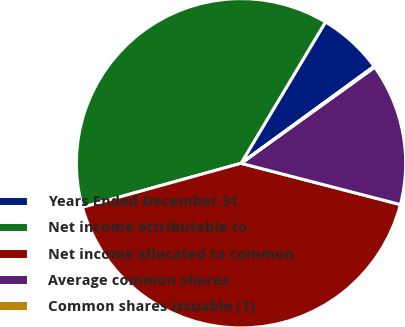<chart> <loc_0><loc_0><loc_500><loc_500><pie_chart><fcel>Years Ended December 31<fcel>Net income attributable to<fcel>Net income allocated to common<fcel>Average common shares<fcel>Common shares issuable (1)<nl><fcel>6.4%<fcel>37.88%<fcel>41.66%<fcel>13.95%<fcel>0.11%<nl></chart> 